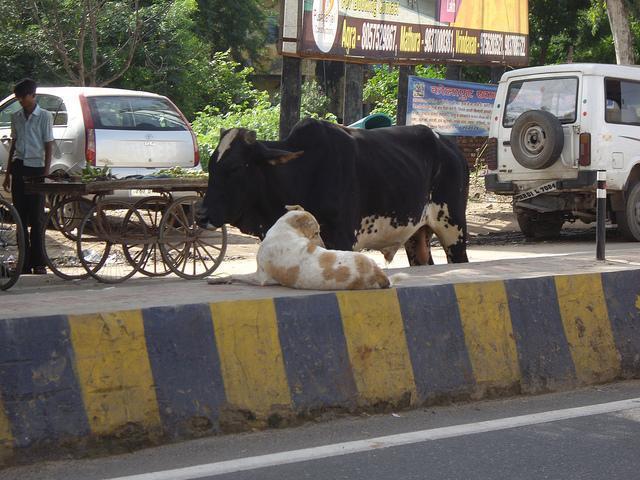How many wheels are on the cart on the left?
Give a very brief answer. 4. How many cows are in the photo?
Give a very brief answer. 1. How many black railroad cars are at the train station?
Give a very brief answer. 0. 